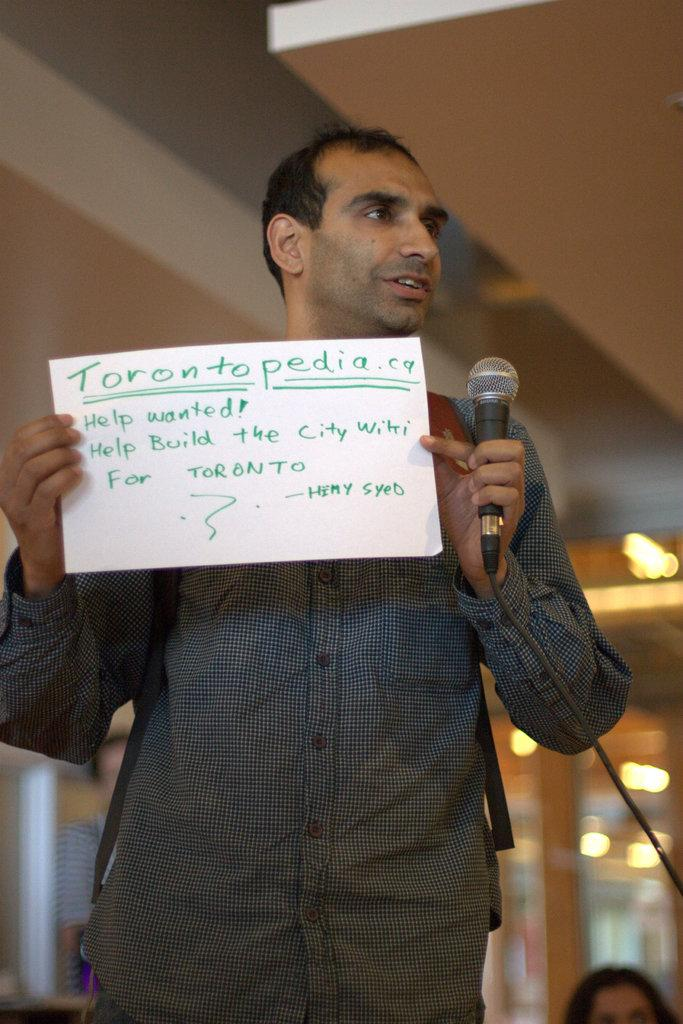Who or what is the main subject of the image? There is a person in the image. What is the person holding in the image? The person is holding a microphone. What type of written information can be seen in the image? There is text written on a paper in the image. What can be seen illuminating the scene in the image? There is a light visible at the top of the image. What type of parcel is being delivered by the person in the image? There is no parcel present in the image; the person is holding a microphone. What is the nature of the argument taking place between the people in the image? There are no people engaged in an argument in the image; only one person holding a microphone is visible. 